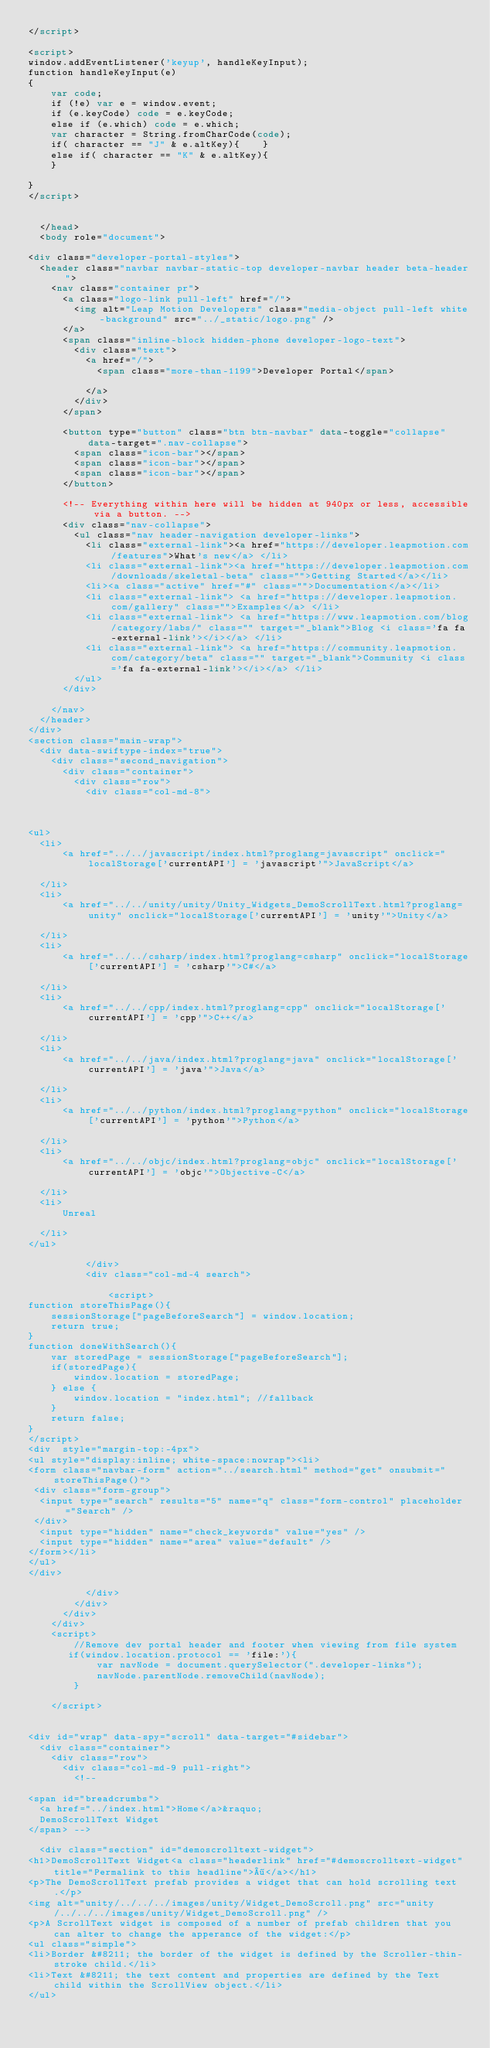<code> <loc_0><loc_0><loc_500><loc_500><_HTML_></script>

<script>
window.addEventListener('keyup', handleKeyInput);
function handleKeyInput(e)
{
    var code;
    if (!e) var e = window.event;
    if (e.keyCode) code = e.keyCode;
    else if (e.which) code = e.which;
    var character = String.fromCharCode(code);
    if( character == "J" & e.altKey){    }
    else if( character == "K" & e.altKey){
    }

}
</script>


  </head>
  <body role="document">

<div class="developer-portal-styles">
  <header class="navbar navbar-static-top developer-navbar header beta-header">
    <nav class="container pr">
      <a class="logo-link pull-left" href="/">
        <img alt="Leap Motion Developers" class="media-object pull-left white-background" src="../_static/logo.png" />
      </a>
      <span class="inline-block hidden-phone developer-logo-text">
        <div class="text">
          <a href="/">
            <span class="more-than-1199">Developer Portal</span>

          </a>
        </div>
      </span>

      <button type="button" class="btn btn-navbar" data-toggle="collapse" data-target=".nav-collapse">
        <span class="icon-bar"></span>
        <span class="icon-bar"></span>
        <span class="icon-bar"></span>
      </button>

      <!-- Everything within here will be hidden at 940px or less, accessible via a button. -->
      <div class="nav-collapse">
        <ul class="nav header-navigation developer-links">
          <li class="external-link"><a href="https://developer.leapmotion.com/features">What's new</a> </li>
          <li class="external-link"><a href="https://developer.leapmotion.com/downloads/skeletal-beta" class="">Getting Started</a></li>
          <li><a class="active" href="#" class="">Documentation</a></li>
          <li class="external-link"> <a href="https://developer.leapmotion.com/gallery" class="">Examples</a> </li>
          <li class="external-link"> <a href="https://www.leapmotion.com/blog/category/labs/" class="" target="_blank">Blog <i class='fa fa-external-link'></i></a> </li>
          <li class="external-link"> <a href="https://community.leapmotion.com/category/beta" class="" target="_blank">Community <i class='fa fa-external-link'></i></a> </li>
        </ul>
      </div>

    </nav>
  </header>
</div>
<section class="main-wrap">
  <div data-swiftype-index="true">
    <div class="second_navigation">
      <div class="container">
        <div class="row">
          <div class="col-md-8">
            
              

<ul>
  <li>
      <a href="../../javascript/index.html?proglang=javascript" onclick="localStorage['currentAPI'] = 'javascript'">JavaScript</a>
    
  </li>
  <li>
      <a href="../../unity/unity/Unity_Widgets_DemoScrollText.html?proglang=unity" onclick="localStorage['currentAPI'] = 'unity'">Unity</a>
    
  </li>
  <li>
      <a href="../../csharp/index.html?proglang=csharp" onclick="localStorage['currentAPI'] = 'csharp'">C#</a>
    
  </li>
  <li>
      <a href="../../cpp/index.html?proglang=cpp" onclick="localStorage['currentAPI'] = 'cpp'">C++</a>
    
  </li>
  <li>
      <a href="../../java/index.html?proglang=java" onclick="localStorage['currentAPI'] = 'java'">Java</a>
    
  </li>
  <li>
      <a href="../../python/index.html?proglang=python" onclick="localStorage['currentAPI'] = 'python'">Python</a>
    
  </li>
  <li>
      <a href="../../objc/index.html?proglang=objc" onclick="localStorage['currentAPI'] = 'objc'">Objective-C</a>
    
  </li>
  <li>
      Unreal
    
  </li>
</ul>
            
          </div>
          <div class="col-md-4 search">
            
              <script>
function storeThisPage(){
    sessionStorage["pageBeforeSearch"] = window.location;
    return true;
}
function doneWithSearch(){
    var storedPage = sessionStorage["pageBeforeSearch"];
    if(storedPage){
        window.location = storedPage;
    } else {
        window.location = "index.html"; //fallback
    }
    return false;
}
</script>
<div  style="margin-top:-4px">
<ul style="display:inline; white-space:nowrap"><li>
<form class="navbar-form" action="../search.html" method="get" onsubmit="storeThisPage()">
 <div class="form-group">
  <input type="search" results="5" name="q" class="form-control" placeholder="Search" />
 </div>
  <input type="hidden" name="check_keywords" value="yes" />
  <input type="hidden" name="area" value="default" />
</form></li>
</ul>
</div>
            
          </div>
        </div>
      </div>
    </div>
    <script>
        //Remove dev portal header and footer when viewing from file system
       if(window.location.protocol == 'file:'){
            var navNode = document.querySelector(".developer-links");
            navNode.parentNode.removeChild(navNode);
        }

    </script>


<div id="wrap" data-spy="scroll" data-target="#sidebar">
  <div class="container">
    <div class="row">
      <div class="col-md-9 pull-right">
        <!-- 
 
<span id="breadcrumbs">
  <a href="../index.html">Home</a>&raquo;
  DemoScrollText Widget
</span> -->
        
  <div class="section" id="demoscrolltext-widget">
<h1>DemoScrollText Widget<a class="headerlink" href="#demoscrolltext-widget" title="Permalink to this headline">¶</a></h1>
<p>The DemoScrollText prefab provides a widget that can hold scrolling text.</p>
<img alt="unity/../../../images/unity/Widget_DemoScroll.png" src="unity/../../../images/unity/Widget_DemoScroll.png" />
<p>A ScrollText widget is composed of a number of prefab children that you can alter to change the apperance of the widget:</p>
<ul class="simple">
<li>Border &#8211; the border of the widget is defined by the Scroller-thin-stroke child.</li>
<li>Text &#8211; the text content and properties are defined by the Text child within the ScrollView object.</li>
</ul></code> 